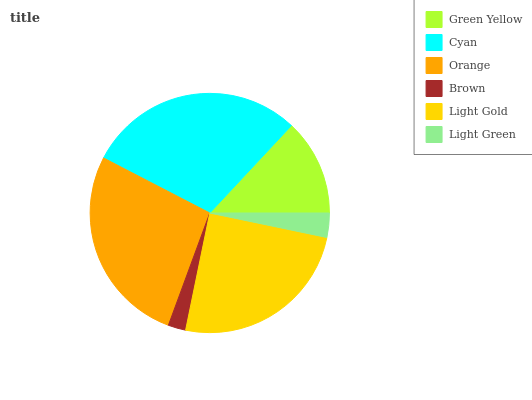Is Brown the minimum?
Answer yes or no. Yes. Is Cyan the maximum?
Answer yes or no. Yes. Is Orange the minimum?
Answer yes or no. No. Is Orange the maximum?
Answer yes or no. No. Is Cyan greater than Orange?
Answer yes or no. Yes. Is Orange less than Cyan?
Answer yes or no. Yes. Is Orange greater than Cyan?
Answer yes or no. No. Is Cyan less than Orange?
Answer yes or no. No. Is Light Gold the high median?
Answer yes or no. Yes. Is Green Yellow the low median?
Answer yes or no. Yes. Is Brown the high median?
Answer yes or no. No. Is Cyan the low median?
Answer yes or no. No. 